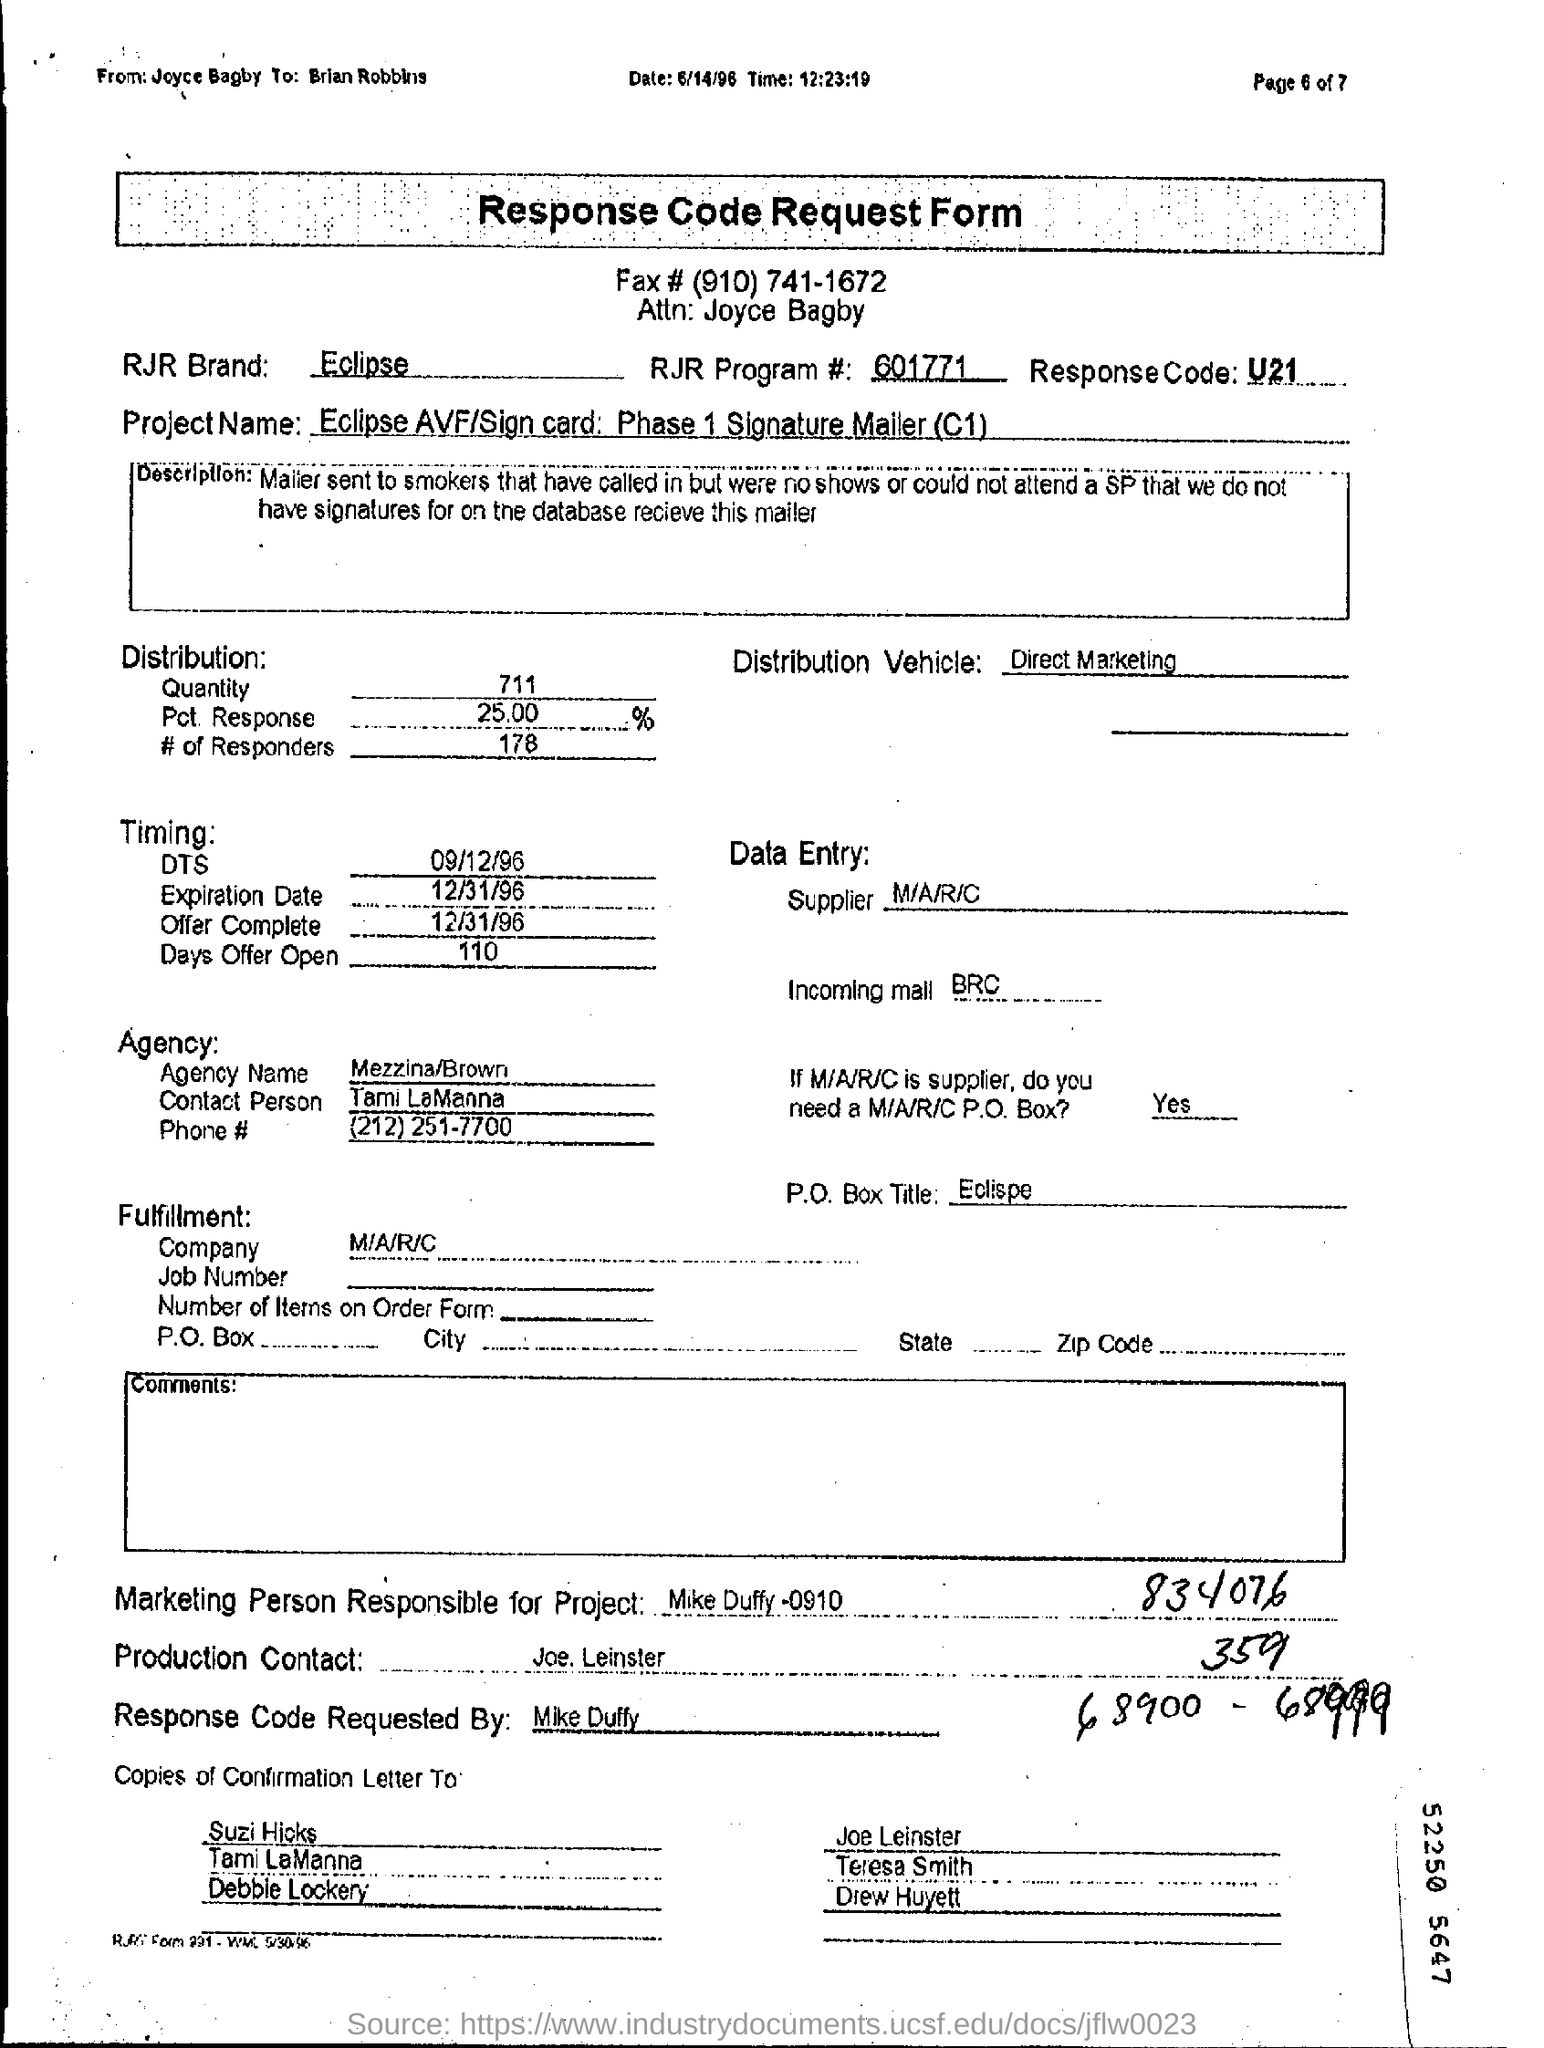Specify some key components in this picture. I am able to identify the brand 'Eclipse' as part of the RJR portfolio. The response code is a numerical value that represents the outcome of a specific action or request. For example, in the case of the message "U21..", the response code of "U21" indicates that the request or action was not successful. 